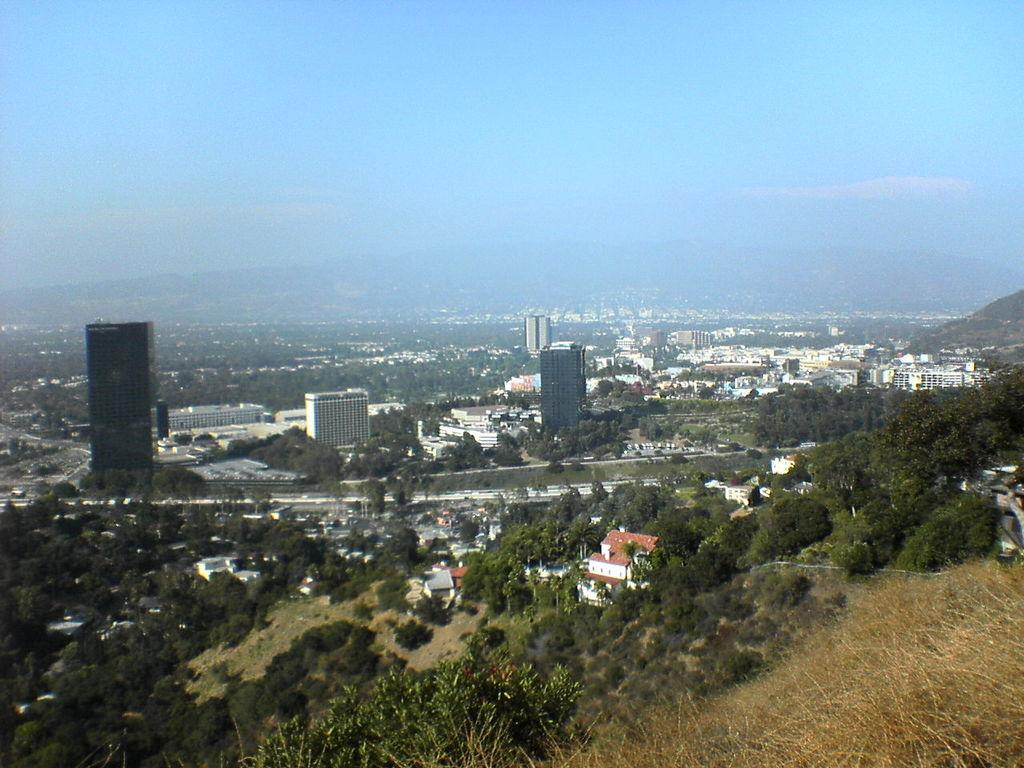What type of natural elements can be seen in the image? There are many trees in the image. What type of man-made structures are present in the image? There are buildings in the image. What is visible at the top of the image? The sky is visible at the top of the image. What degree of difficulty is the kite flying in the image? There is no kite present in the image, so it is not possible to determine the degree of difficulty for flying a kite. How many sticks are visible in the image? There are no sticks visible in the image. 